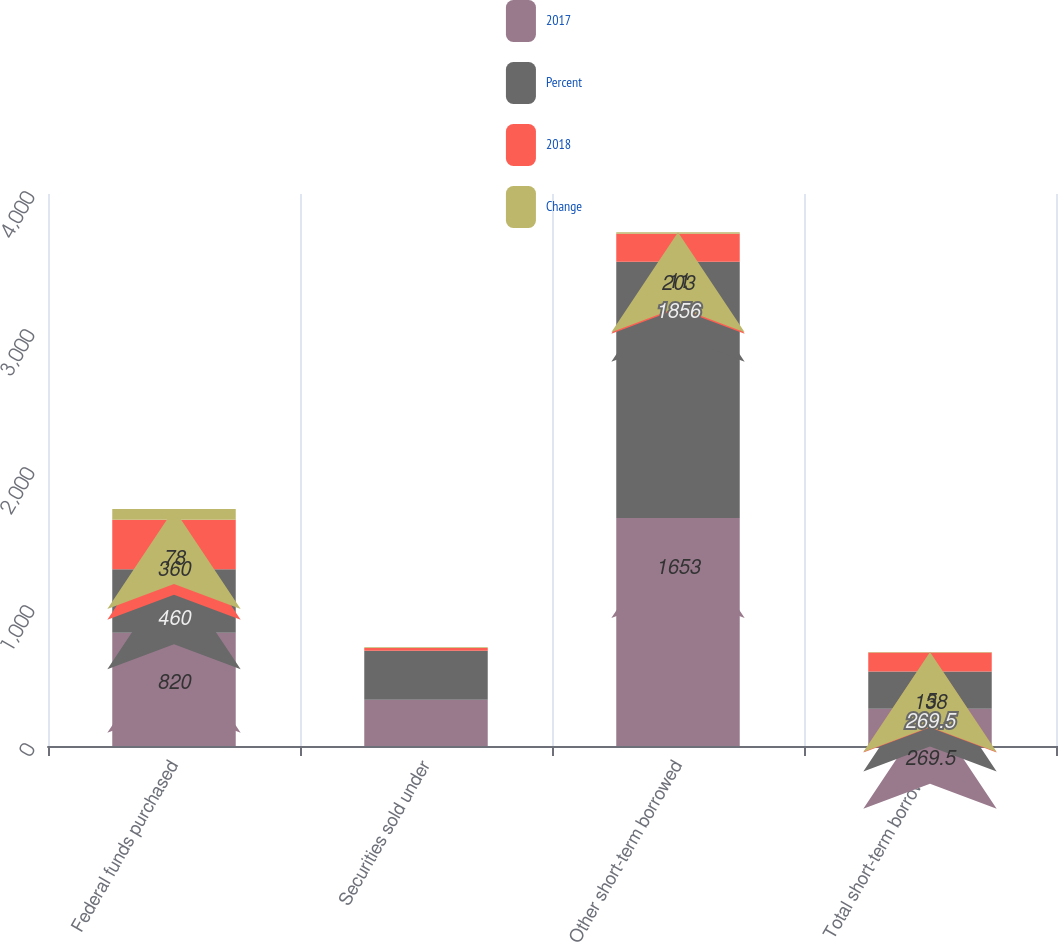Convert chart to OTSL. <chart><loc_0><loc_0><loc_500><loc_500><stacked_bar_chart><ecel><fcel>Federal funds purchased<fcel>Securities sold under<fcel>Other short-term borrowed<fcel>Total short-term borrowed<nl><fcel>2017<fcel>820<fcel>336<fcel>1653<fcel>269.5<nl><fcel>Percent<fcel>460<fcel>355<fcel>1856<fcel>269.5<nl><fcel>2018<fcel>360<fcel>19<fcel>203<fcel>138<nl><fcel>Change<fcel>78<fcel>5<fcel>11<fcel>5<nl></chart> 